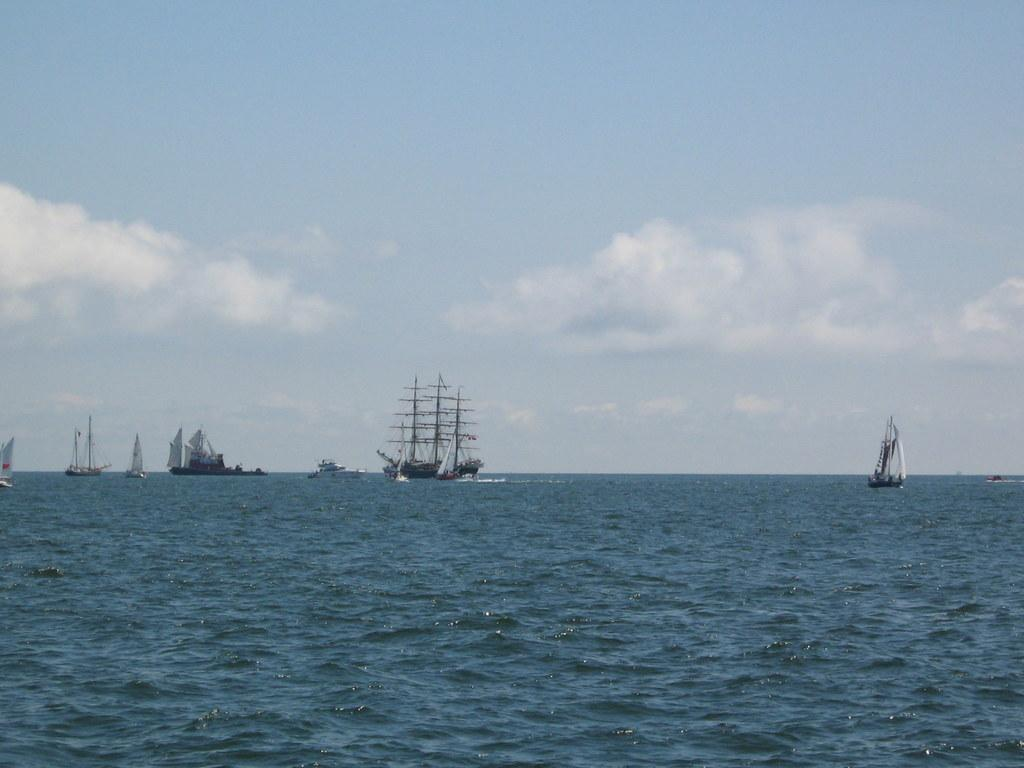What is the main feature of the picture? The main feature of the picture is an ocean. What is happening on the ocean in the picture? There are ships sailing on the ocean in the picture. How would you describe the sky in the picture? The sky is clear in the picture. Can you see a quiver of arrows on any of the ships in the picture? There is no quiver of arrows visible on any of the ships in the picture. Are there any horses present in the picture? There are no horses present in the picture; it features an ocean with ships sailing on it. 